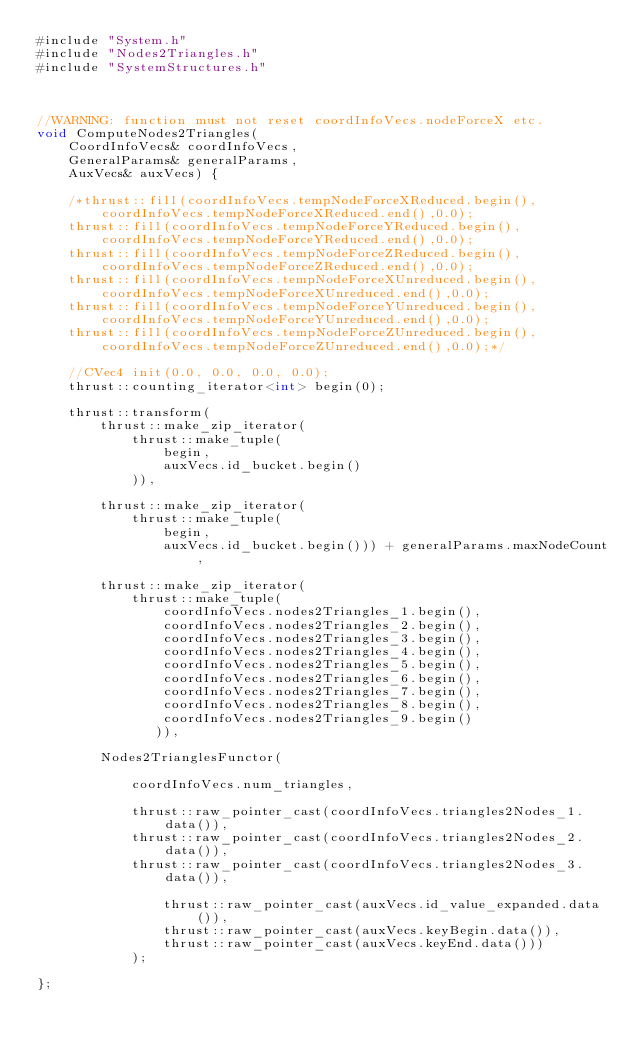Convert code to text. <code><loc_0><loc_0><loc_500><loc_500><_Cuda_>#include "System.h"
#include "Nodes2Triangles.h"
#include "SystemStructures.h"



//WARNING: function must not reset coordInfoVecs.nodeForceX etc. 
void ComputeNodes2Triangles(
    CoordInfoVecs& coordInfoVecs,
    GeneralParams& generalParams,
    AuxVecs& auxVecs) {    
    
    /*thrust::fill(coordInfoVecs.tempNodeForceXReduced.begin(),coordInfoVecs.tempNodeForceXReduced.end(),0.0);
    thrust::fill(coordInfoVecs.tempNodeForceYReduced.begin(),coordInfoVecs.tempNodeForceYReduced.end(),0.0);
    thrust::fill(coordInfoVecs.tempNodeForceZReduced.begin(),coordInfoVecs.tempNodeForceZReduced.end(),0.0);
    thrust::fill(coordInfoVecs.tempNodeForceXUnreduced.begin(),coordInfoVecs.tempNodeForceXUnreduced.end(),0.0);
    thrust::fill(coordInfoVecs.tempNodeForceYUnreduced.begin(),coordInfoVecs.tempNodeForceYUnreduced.end(),0.0);
    thrust::fill(coordInfoVecs.tempNodeForceZUnreduced.begin(),coordInfoVecs.tempNodeForceZUnreduced.end(),0.0);*/

    //CVec4 init(0.0, 0.0, 0.0, 0.0); 
    thrust::counting_iterator<int> begin(0);

    thrust::transform(  
        thrust::make_zip_iterator(
            thrust::make_tuple(
                begin,
                auxVecs.id_bucket.begin()
            )),
        
        thrust::make_zip_iterator(
            thrust::make_tuple(
                begin,
                auxVecs.id_bucket.begin())) + generalParams.maxNodeCount,

        thrust::make_zip_iterator(
            thrust::make_tuple(
                coordInfoVecs.nodes2Triangles_1.begin(),
                coordInfoVecs.nodes2Triangles_2.begin(),
                coordInfoVecs.nodes2Triangles_3.begin(),
                coordInfoVecs.nodes2Triangles_4.begin(),
                coordInfoVecs.nodes2Triangles_5.begin(),
                coordInfoVecs.nodes2Triangles_6.begin(),
                coordInfoVecs.nodes2Triangles_7.begin(),
                coordInfoVecs.nodes2Triangles_8.begin(),
                coordInfoVecs.nodes2Triangles_9.begin()
               )),

        Nodes2TrianglesFunctor(
            
            coordInfoVecs.num_triangles,

            thrust::raw_pointer_cast(coordInfoVecs.triangles2Nodes_1.data()),
            thrust::raw_pointer_cast(coordInfoVecs.triangles2Nodes_2.data()),
            thrust::raw_pointer_cast(coordInfoVecs.triangles2Nodes_3.data()),              
                          
                thrust::raw_pointer_cast(auxVecs.id_value_expanded.data()),
                thrust::raw_pointer_cast(auxVecs.keyBegin.data()),
                thrust::raw_pointer_cast(auxVecs.keyEnd.data()))
            );
                     
};

</code> 